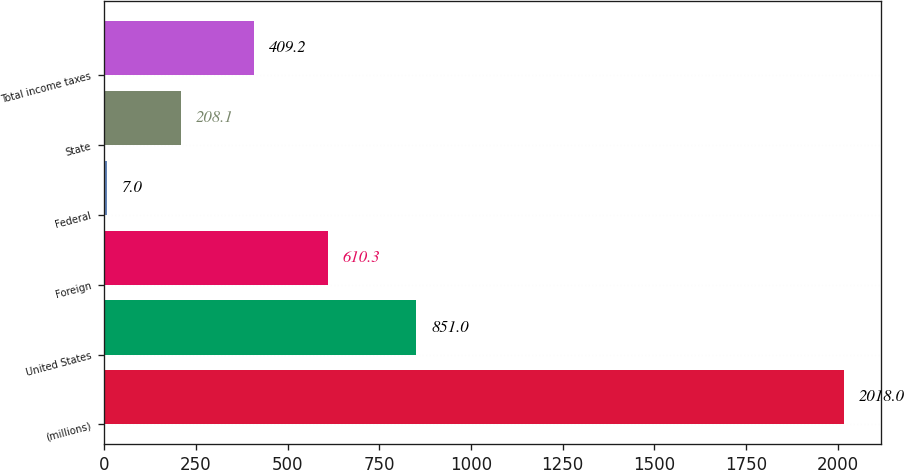Convert chart to OTSL. <chart><loc_0><loc_0><loc_500><loc_500><bar_chart><fcel>(millions)<fcel>United States<fcel>Foreign<fcel>Federal<fcel>State<fcel>Total income taxes<nl><fcel>2018<fcel>851<fcel>610.3<fcel>7<fcel>208.1<fcel>409.2<nl></chart> 